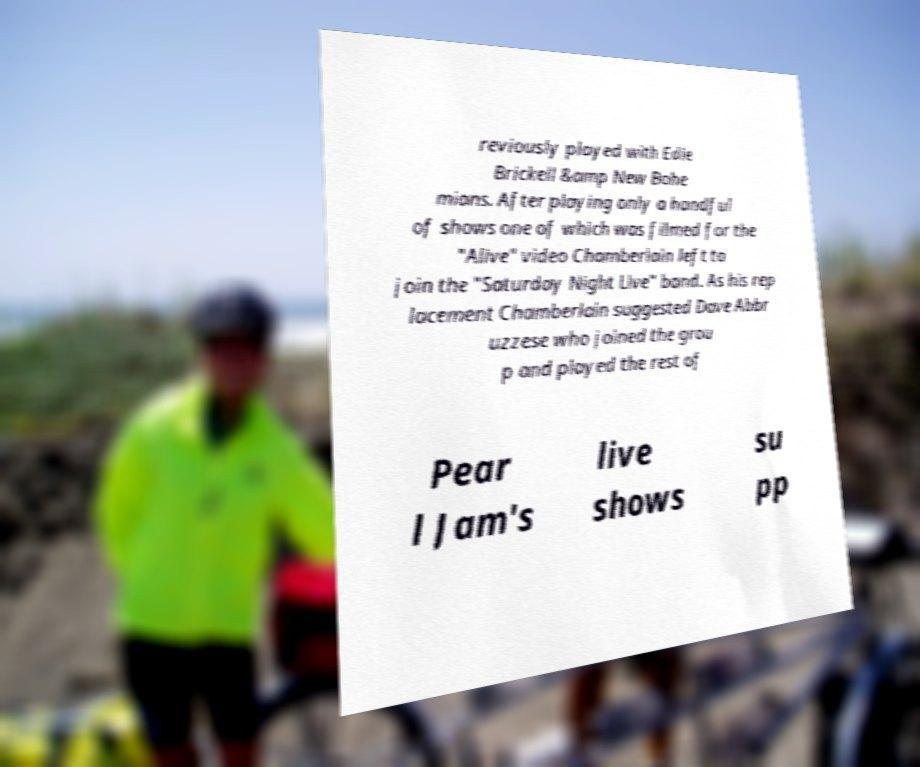What messages or text are displayed in this image? I need them in a readable, typed format. reviously played with Edie Brickell &amp New Bohe mians. After playing only a handful of shows one of which was filmed for the "Alive" video Chamberlain left to join the "Saturday Night Live" band. As his rep lacement Chamberlain suggested Dave Abbr uzzese who joined the grou p and played the rest of Pear l Jam's live shows su pp 